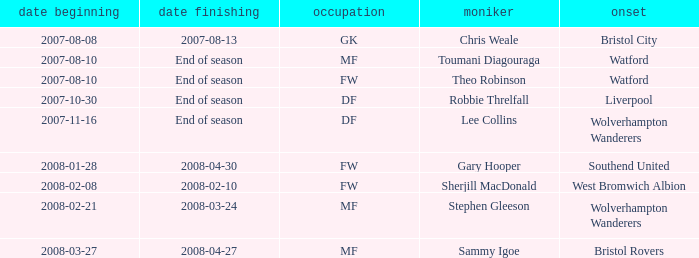Where was the player from who had the position of DF, who started 2007-10-30? Liverpool. 